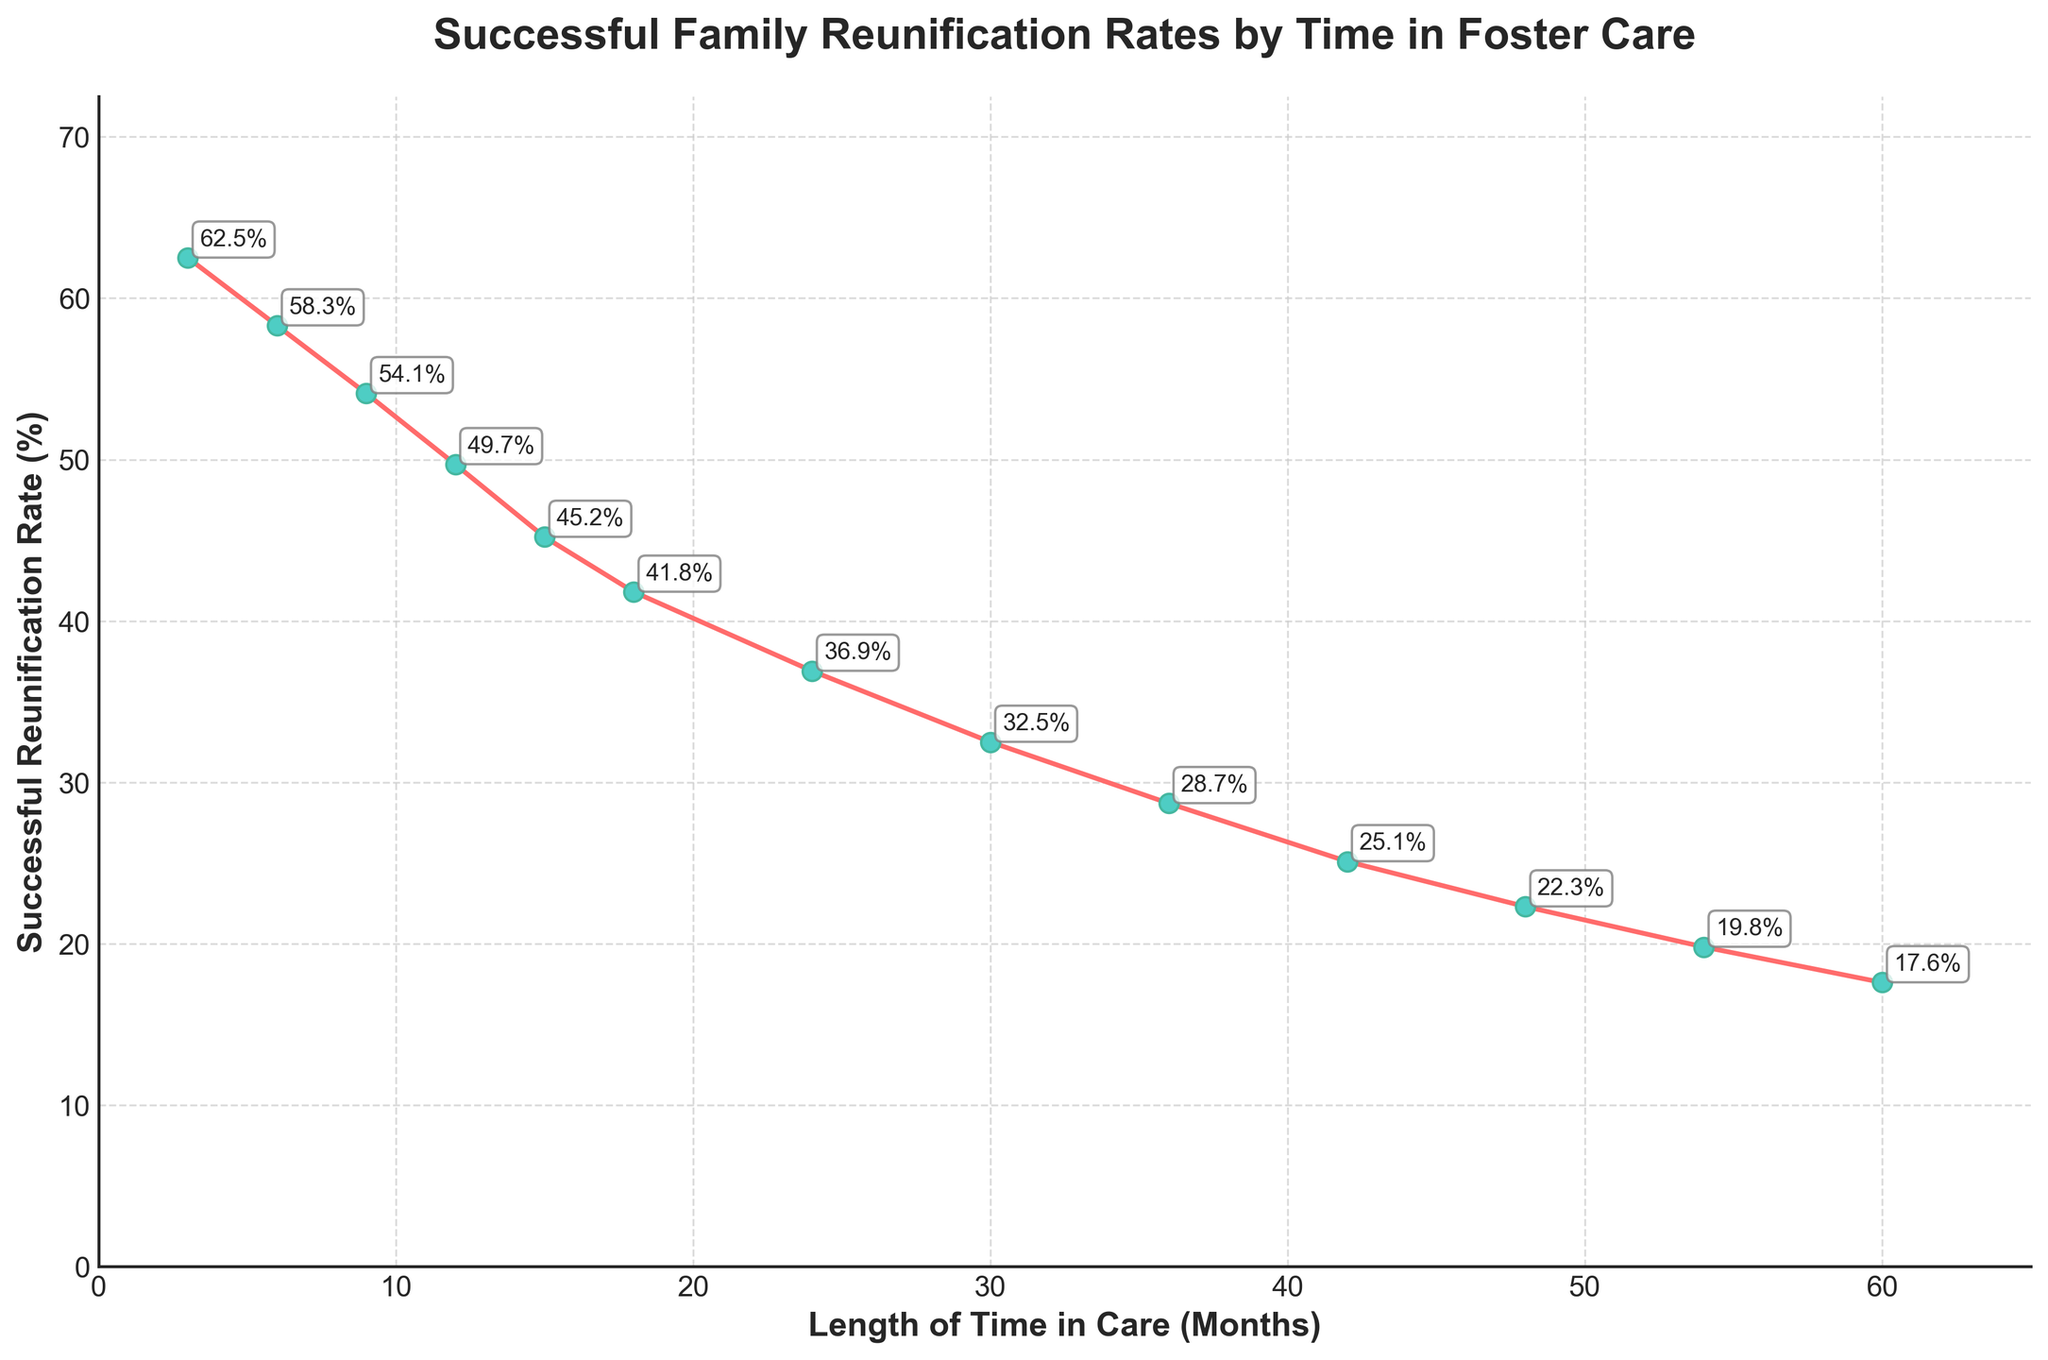What is the successful reunification rate at 12 months? Locate the data point at 12 months on the x-axis and refer to the corresponding y-value, which is 49.7%.
Answer: 49.7% How much does the successful reunification rate decrease from 6 months to 24 months? Find the successful reunification rate at 6 months (58.3%) and at 24 months (36.9%) on the y-axis, then calculate the difference: 58.3% - 36.9% = 21.4%.
Answer: 21.4% What is the difference in the successful reunification rate between 9 months and 54 months? The successful reunification rate at 9 months is 54.1%, and at 54 months it is 19.8%; calculate the difference: 54.1% - 19.8% = 34.3%.
Answer: 34.3% Between which two consecutive points does the successful reunification rate drop the most? By comparing the drops between each consecutive data point, the largest drop occurs between 9 months (54.1%) and 12 months (49.7%), which is 4.4%.
Answer: Between 9 and 12 months Which period shows a faster decline in successful reunification rate: from 3 to 18 months or from 18 to 60 months? Calculate the decline from 3 to 18 months: 62.5% (at 3 months) - 41.8% (at 18 months) = 20.7%. Calculate the decline from 18 to 60 months: 41.8% - 17.6% = 24.2%. The period from 18 to 60 months has a faster decline.
Answer: 18 to 60 months At which month does the successful reunification rate go below 30%? Identify the first month where the rate drops below 30%. It is 36 months with a rate of 28.7%.
Answer: 36 months Which segment of the curve is steepest, indicating the fastest rate of decline? Visually inspect the plot to identify the segment with the steepest slope, which appears to be between 3 months (62.5%) and 12 months (49.7%).
Answer: 3 to 12 months What is the average successful reunification rate for the first 24 months? Sum the rates for the first 24 months (62.5%, 58.3%, 54.1%, 49.7%, 45.2%, 41.8%, 36.9%) = 348.5%, then divide by the number of data points (7): 348.5% / 7 ≈ 49.79%.
Answer: 49.79% How much lower is the successful reunification rate at 60 months compared to 3 months? The rate at 3 months is 62.5% and at 60 months is 17.6%. Calculate the difference: 62.5% - 17.6% = 44.9%.
Answer: 44.9% 